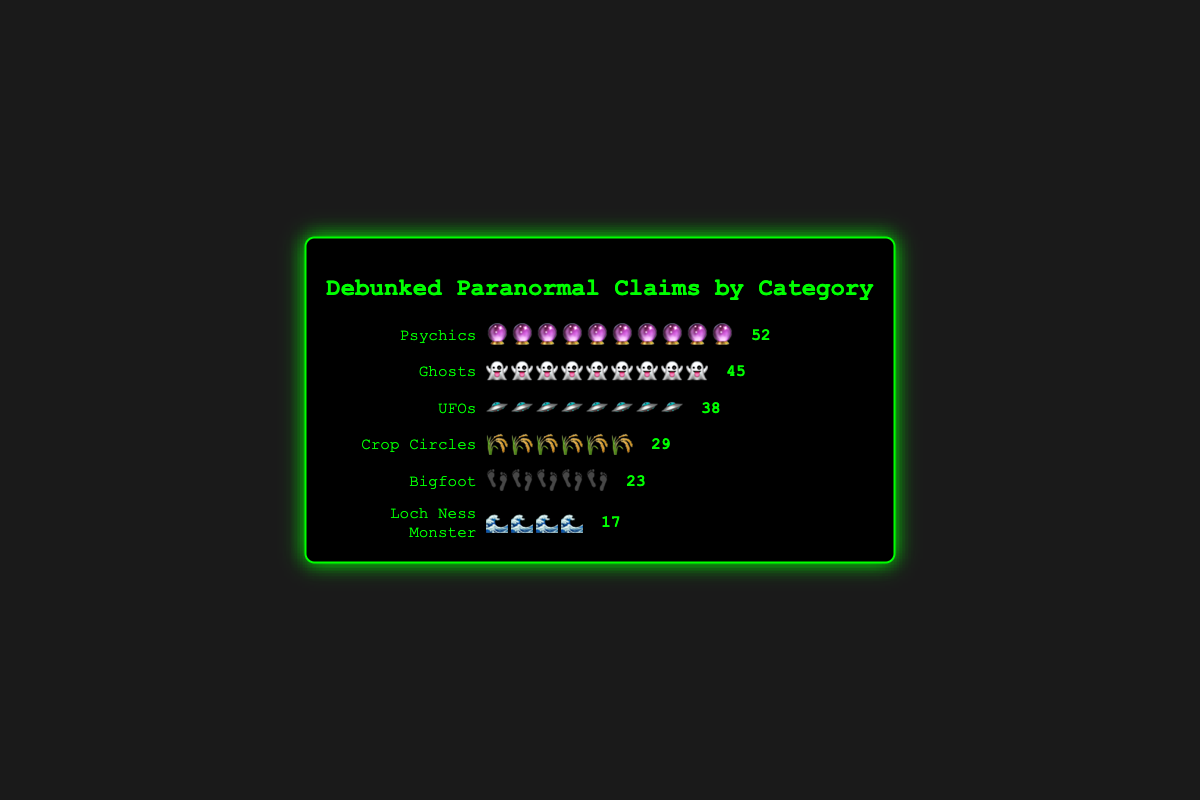What is the title of the plot? The title of the plot is located at the top center of the figure. It reads "Debunked Paranormal Claims by Category".
Answer: Debunked Paranormal Claims by Category Which category has the highest number of debunked claims? The category with the highest number of debunked claims can be identified by the length of the icon rows and the number next to them. "Psychics" has the highest count with 52 debunked claims.
Answer: Psychics How many total debunked claims are there? Sum all the debunked claims from each category: 45 (Ghosts) + 38 (UFOs) + 52 (Psychics) + 23 (Bigfoot) + 17 (Loch Ness Monster) + 29 (Crop Circles) = 204.
Answer: 204 What is the difference in the number of debunked claims between "Ghosts" and "Crop Circles"? Subtract the number of debunked claims of Crop Circles from Ghosts: 45 (Ghosts) - 29 (Crop Circles) = 16.
Answer: 16 Which category has the fewest debunked claims, and how many does it have? By examining the lengths of the icon rows and the numbers, the "Loch Ness Monster" category has the fewest debunked claims with 17.
Answer: Loch Ness Monster, 17 How does the number of debunked Bigfoot claims compare to UFO claims? Compare the numbers next to the icons for Bigfoot (23) and UFOs (38). The UFOs have more debunked claims than Bigfoot.
Answer: UFOs have more Are there more debunked claims for Crop Circles or for Bigfoot? Compare the numbers next to the icons for Crop Circles (29) and Bigfoot (23). Crop Circles have more debunked claims than Bigfoot.
Answer: Crop Circles have more What types of icons are used for the category "Ghosts"? Look at the icons in the row corresponding to "Ghosts". The icon used is a ghost emoji (👻), which appears multiple times.
Answer: ghost emojis How many more debunked claims are there for Psychics compared to UFOs? Subtract the number of debunked claims of UFOs from Psychics: 52 (Psychics) - 38 (UFOs) = 14.
Answer: 14 What is the combined total of debunked claims for Ghosts, UFOs, and Crop Circles? Sum the debunked claims for these categories: 45 (Ghosts) + 38 (UFOs) + 29 (Crop Circles) = 112.
Answer: 112 